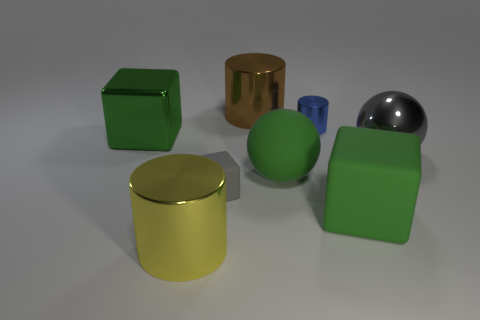Add 1 big yellow shiny cylinders. How many objects exist? 9 Subtract all large cylinders. How many cylinders are left? 1 Subtract 1 blocks. How many blocks are left? 2 Add 4 small blue shiny cylinders. How many small blue shiny cylinders are left? 5 Add 1 gray rubber blocks. How many gray rubber blocks exist? 2 Subtract all gray blocks. How many blocks are left? 2 Subtract 1 green spheres. How many objects are left? 7 Subtract all cubes. How many objects are left? 5 Subtract all gray cylinders. Subtract all gray cubes. How many cylinders are left? 3 Subtract all yellow cylinders. How many cyan cubes are left? 0 